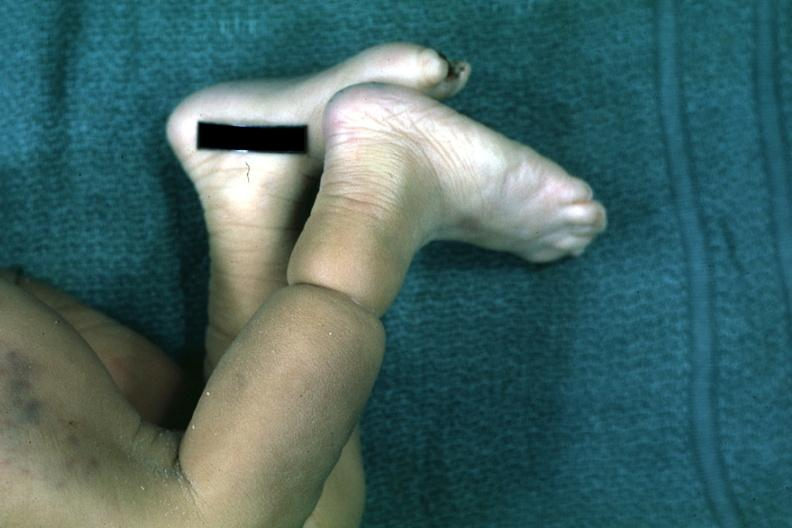s that present?
Answer the question using a single word or phrase. No 